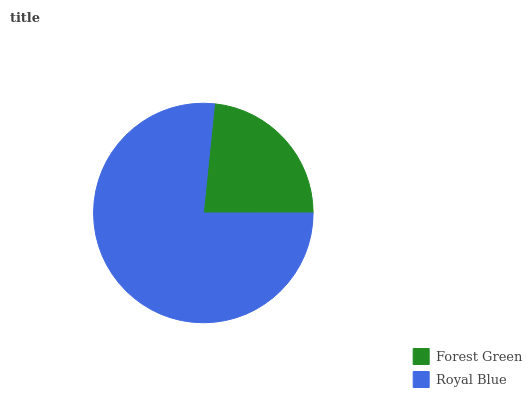Is Forest Green the minimum?
Answer yes or no. Yes. Is Royal Blue the maximum?
Answer yes or no. Yes. Is Royal Blue the minimum?
Answer yes or no. No. Is Royal Blue greater than Forest Green?
Answer yes or no. Yes. Is Forest Green less than Royal Blue?
Answer yes or no. Yes. Is Forest Green greater than Royal Blue?
Answer yes or no. No. Is Royal Blue less than Forest Green?
Answer yes or no. No. Is Royal Blue the high median?
Answer yes or no. Yes. Is Forest Green the low median?
Answer yes or no. Yes. Is Forest Green the high median?
Answer yes or no. No. Is Royal Blue the low median?
Answer yes or no. No. 